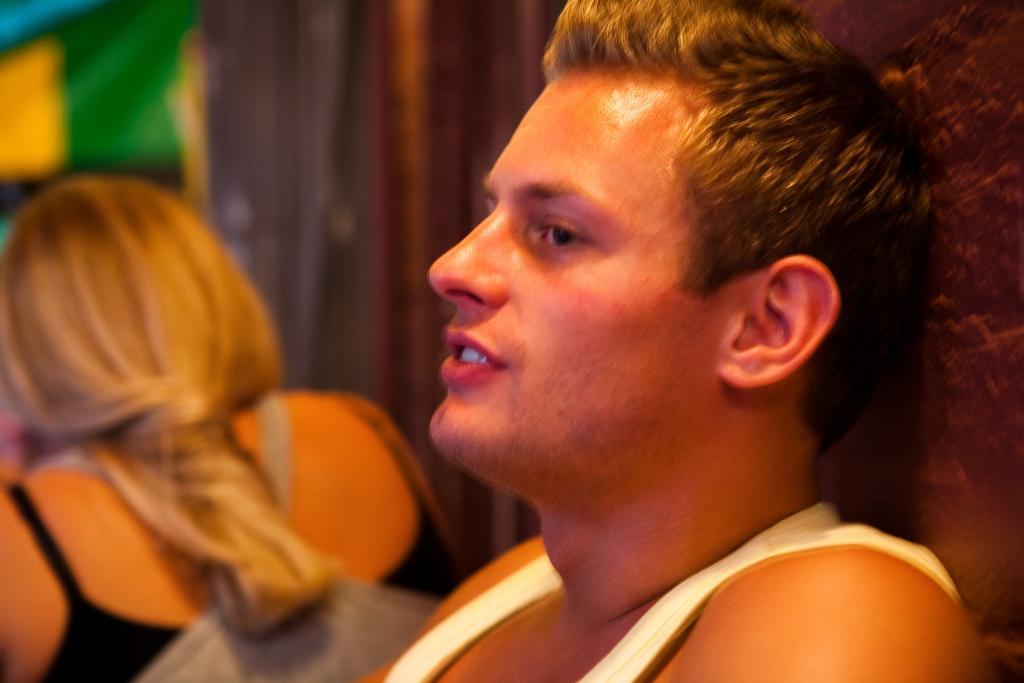Can you describe this image briefly? Background portion of the picture is blur. We can see a person with light brown hair. On the right side of the picture we can see a man. 